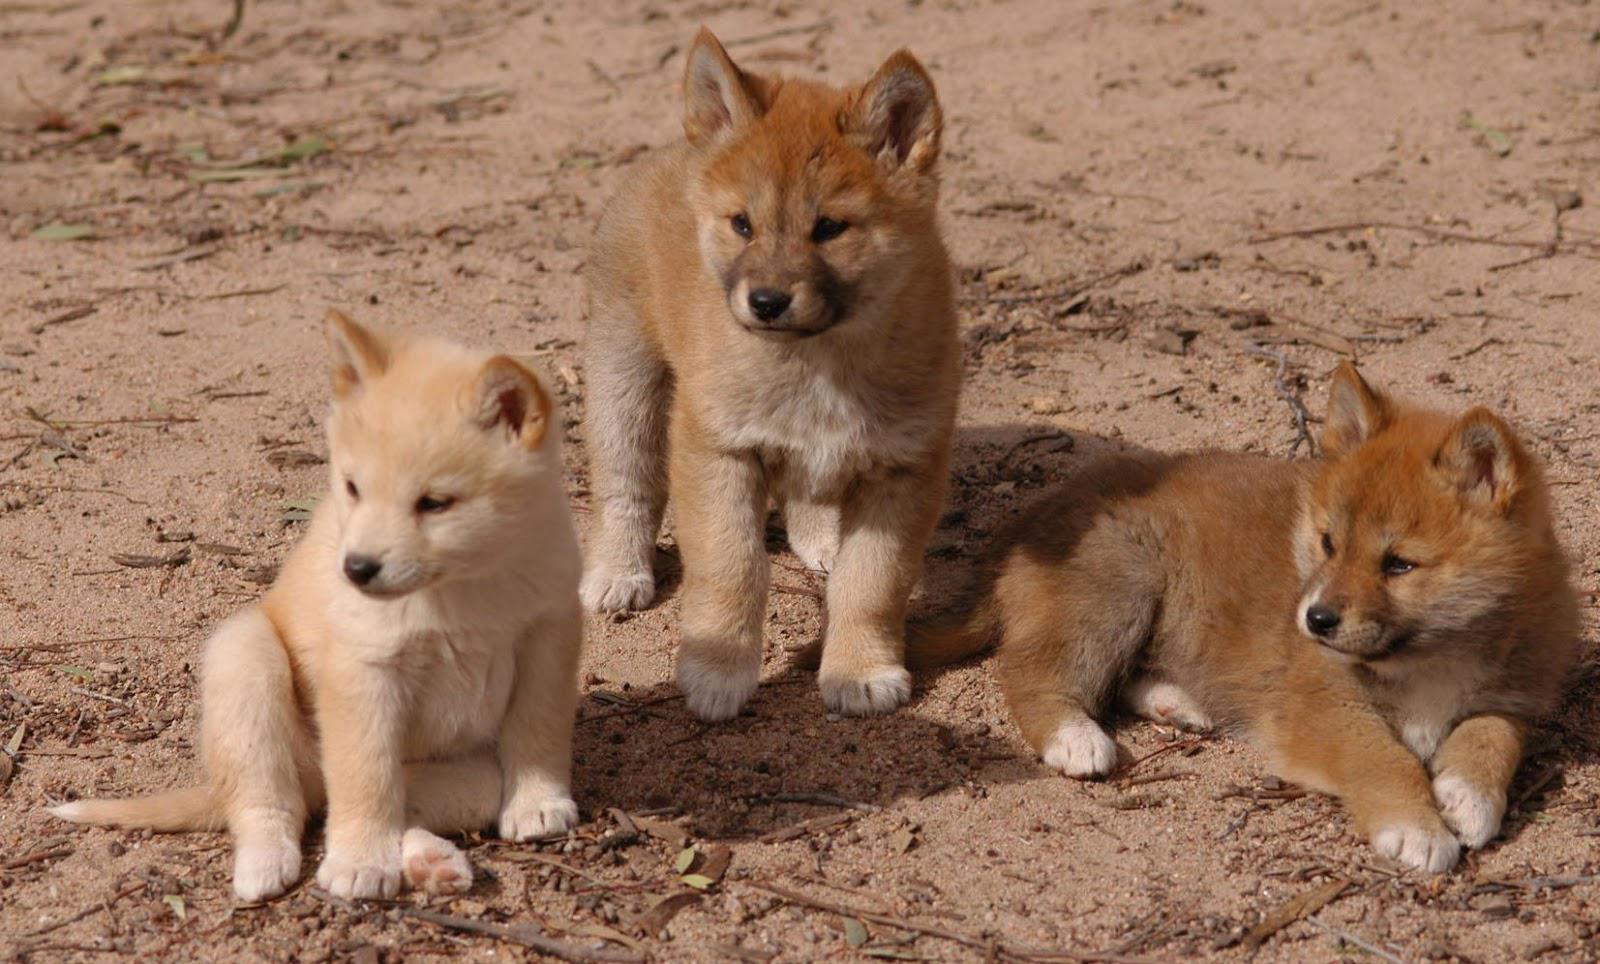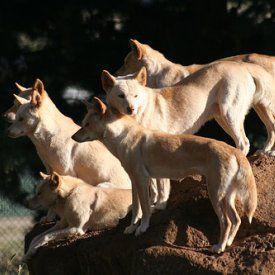The first image is the image on the left, the second image is the image on the right. Assess this claim about the two images: "None of the animals are lying down.". Correct or not? Answer yes or no. No. The first image is the image on the left, the second image is the image on the right. Examine the images to the left and right. Is the description "There are 3 dogs in one of the images." accurate? Answer yes or no. Yes. 